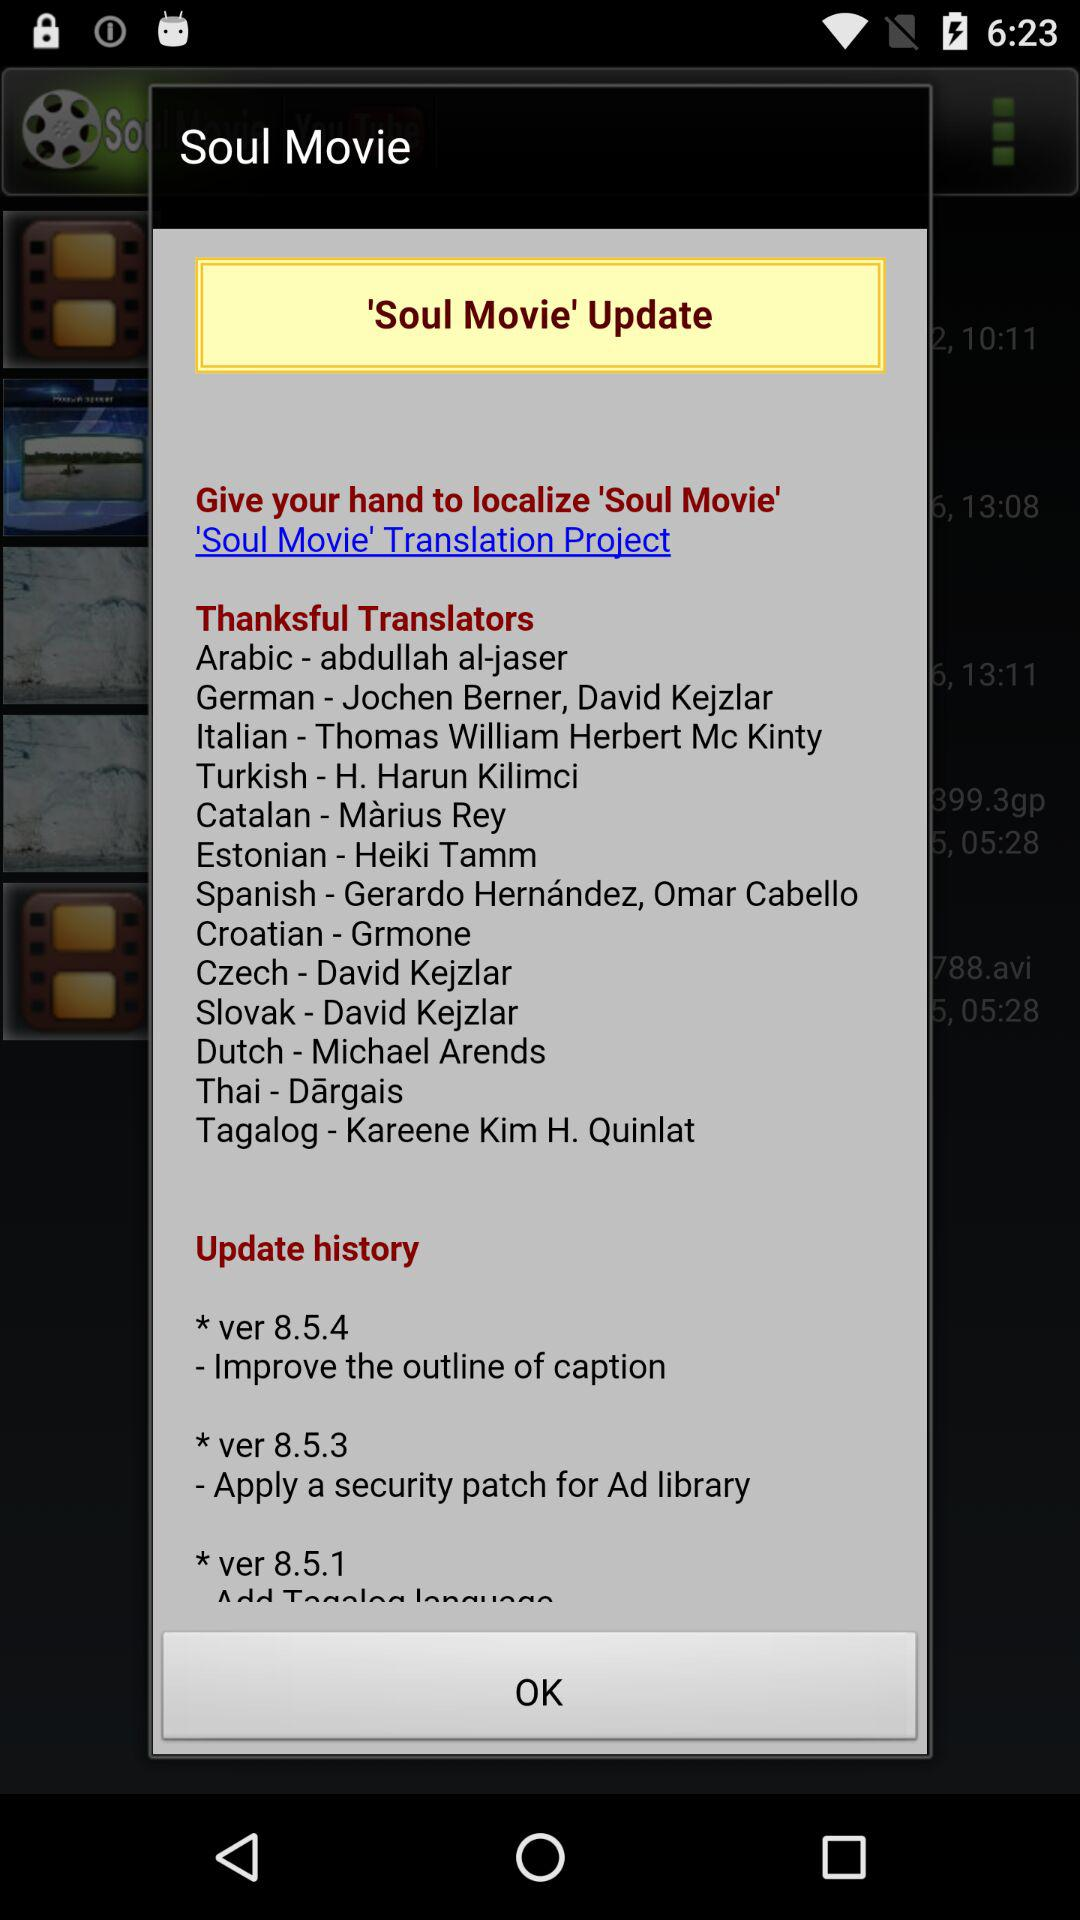What is the name of the Arabic translators? The name of the Arabic translator is "abdullah al-jaser". 